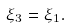Convert formula to latex. <formula><loc_0><loc_0><loc_500><loc_500>\xi _ { 3 } = \xi _ { 1 } .</formula> 